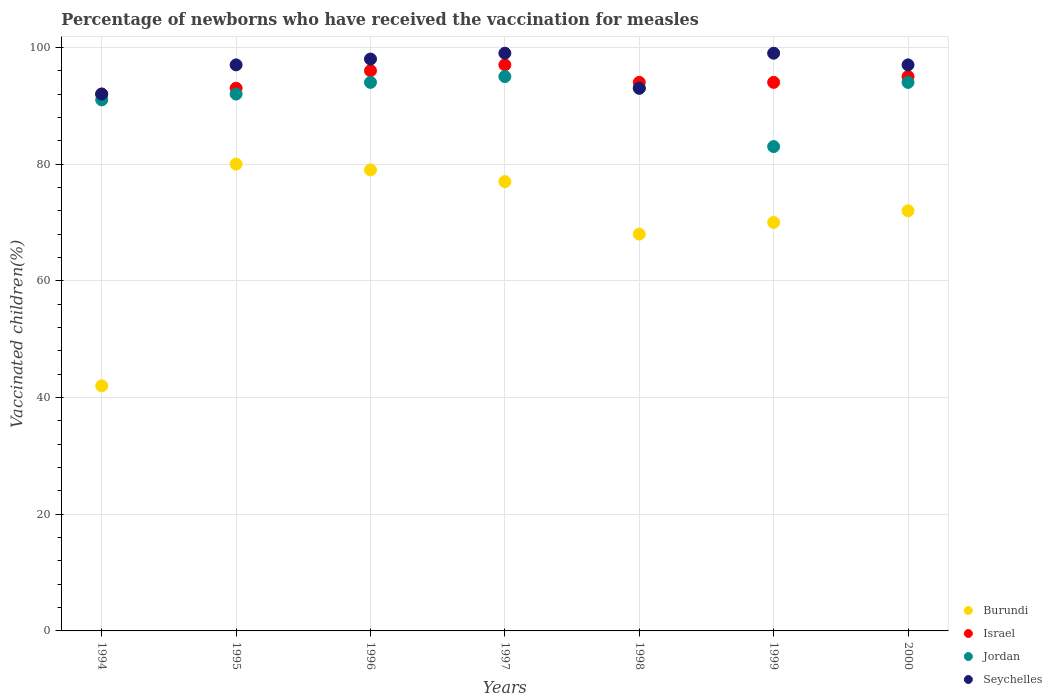How many different coloured dotlines are there?
Your response must be concise. 4. What is the percentage of vaccinated children in Israel in 1996?
Provide a succinct answer. 96. Across all years, what is the maximum percentage of vaccinated children in Burundi?
Provide a succinct answer. 80. Across all years, what is the minimum percentage of vaccinated children in Israel?
Provide a short and direct response. 92. In which year was the percentage of vaccinated children in Israel minimum?
Make the answer very short. 1994. What is the total percentage of vaccinated children in Burundi in the graph?
Your response must be concise. 488. What is the difference between the percentage of vaccinated children in Jordan in 1996 and that in 1998?
Give a very brief answer. 1. What is the average percentage of vaccinated children in Burundi per year?
Provide a succinct answer. 69.71. In the year 2000, what is the difference between the percentage of vaccinated children in Seychelles and percentage of vaccinated children in Israel?
Offer a terse response. 2. In how many years, is the percentage of vaccinated children in Jordan greater than 92 %?
Your answer should be very brief. 4. What is the ratio of the percentage of vaccinated children in Seychelles in 1999 to that in 2000?
Offer a terse response. 1.02. Is the difference between the percentage of vaccinated children in Seychelles in 1996 and 1997 greater than the difference between the percentage of vaccinated children in Israel in 1996 and 1997?
Keep it short and to the point. No. What is the difference between the highest and the lowest percentage of vaccinated children in Burundi?
Your answer should be compact. 38. In how many years, is the percentage of vaccinated children in Seychelles greater than the average percentage of vaccinated children in Seychelles taken over all years?
Ensure brevity in your answer.  5. Is the sum of the percentage of vaccinated children in Israel in 1996 and 2000 greater than the maximum percentage of vaccinated children in Jordan across all years?
Offer a terse response. Yes. Is it the case that in every year, the sum of the percentage of vaccinated children in Seychelles and percentage of vaccinated children in Israel  is greater than the sum of percentage of vaccinated children in Jordan and percentage of vaccinated children in Burundi?
Give a very brief answer. No. Is it the case that in every year, the sum of the percentage of vaccinated children in Seychelles and percentage of vaccinated children in Jordan  is greater than the percentage of vaccinated children in Burundi?
Offer a terse response. Yes. Is the percentage of vaccinated children in Seychelles strictly less than the percentage of vaccinated children in Jordan over the years?
Offer a very short reply. No. How many dotlines are there?
Provide a short and direct response. 4. How many years are there in the graph?
Your answer should be very brief. 7. What is the difference between two consecutive major ticks on the Y-axis?
Provide a succinct answer. 20. Does the graph contain any zero values?
Make the answer very short. No. Does the graph contain grids?
Provide a short and direct response. Yes. How are the legend labels stacked?
Keep it short and to the point. Vertical. What is the title of the graph?
Your answer should be very brief. Percentage of newborns who have received the vaccination for measles. Does "Low & middle income" appear as one of the legend labels in the graph?
Offer a terse response. No. What is the label or title of the Y-axis?
Your answer should be very brief. Vaccinated children(%). What is the Vaccinated children(%) of Burundi in 1994?
Your answer should be very brief. 42. What is the Vaccinated children(%) in Israel in 1994?
Offer a very short reply. 92. What is the Vaccinated children(%) of Jordan in 1994?
Provide a succinct answer. 91. What is the Vaccinated children(%) in Seychelles in 1994?
Ensure brevity in your answer.  92. What is the Vaccinated children(%) in Burundi in 1995?
Give a very brief answer. 80. What is the Vaccinated children(%) of Israel in 1995?
Make the answer very short. 93. What is the Vaccinated children(%) in Jordan in 1995?
Make the answer very short. 92. What is the Vaccinated children(%) in Seychelles in 1995?
Keep it short and to the point. 97. What is the Vaccinated children(%) in Burundi in 1996?
Offer a very short reply. 79. What is the Vaccinated children(%) of Israel in 1996?
Give a very brief answer. 96. What is the Vaccinated children(%) of Jordan in 1996?
Your response must be concise. 94. What is the Vaccinated children(%) in Seychelles in 1996?
Provide a succinct answer. 98. What is the Vaccinated children(%) of Israel in 1997?
Ensure brevity in your answer.  97. What is the Vaccinated children(%) in Jordan in 1997?
Your answer should be very brief. 95. What is the Vaccinated children(%) of Seychelles in 1997?
Your answer should be compact. 99. What is the Vaccinated children(%) in Burundi in 1998?
Your answer should be very brief. 68. What is the Vaccinated children(%) of Israel in 1998?
Provide a short and direct response. 94. What is the Vaccinated children(%) in Jordan in 1998?
Provide a short and direct response. 93. What is the Vaccinated children(%) of Seychelles in 1998?
Keep it short and to the point. 93. What is the Vaccinated children(%) in Burundi in 1999?
Offer a terse response. 70. What is the Vaccinated children(%) in Israel in 1999?
Your answer should be very brief. 94. What is the Vaccinated children(%) of Jordan in 1999?
Provide a short and direct response. 83. What is the Vaccinated children(%) in Israel in 2000?
Make the answer very short. 95. What is the Vaccinated children(%) of Jordan in 2000?
Provide a succinct answer. 94. What is the Vaccinated children(%) in Seychelles in 2000?
Offer a very short reply. 97. Across all years, what is the maximum Vaccinated children(%) in Burundi?
Your response must be concise. 80. Across all years, what is the maximum Vaccinated children(%) in Israel?
Provide a succinct answer. 97. Across all years, what is the maximum Vaccinated children(%) of Seychelles?
Offer a very short reply. 99. Across all years, what is the minimum Vaccinated children(%) of Israel?
Ensure brevity in your answer.  92. Across all years, what is the minimum Vaccinated children(%) in Seychelles?
Your answer should be compact. 92. What is the total Vaccinated children(%) in Burundi in the graph?
Give a very brief answer. 488. What is the total Vaccinated children(%) in Israel in the graph?
Your answer should be very brief. 661. What is the total Vaccinated children(%) of Jordan in the graph?
Provide a succinct answer. 642. What is the total Vaccinated children(%) in Seychelles in the graph?
Your answer should be compact. 675. What is the difference between the Vaccinated children(%) of Burundi in 1994 and that in 1995?
Ensure brevity in your answer.  -38. What is the difference between the Vaccinated children(%) in Israel in 1994 and that in 1995?
Your answer should be very brief. -1. What is the difference between the Vaccinated children(%) in Jordan in 1994 and that in 1995?
Offer a terse response. -1. What is the difference between the Vaccinated children(%) of Burundi in 1994 and that in 1996?
Offer a very short reply. -37. What is the difference between the Vaccinated children(%) of Seychelles in 1994 and that in 1996?
Offer a very short reply. -6. What is the difference between the Vaccinated children(%) in Burundi in 1994 and that in 1997?
Your answer should be very brief. -35. What is the difference between the Vaccinated children(%) in Jordan in 1994 and that in 1997?
Your answer should be compact. -4. What is the difference between the Vaccinated children(%) of Seychelles in 1994 and that in 1997?
Provide a short and direct response. -7. What is the difference between the Vaccinated children(%) in Burundi in 1994 and that in 1998?
Provide a short and direct response. -26. What is the difference between the Vaccinated children(%) in Seychelles in 1994 and that in 1998?
Ensure brevity in your answer.  -1. What is the difference between the Vaccinated children(%) of Burundi in 1994 and that in 1999?
Give a very brief answer. -28. What is the difference between the Vaccinated children(%) in Jordan in 1994 and that in 1999?
Give a very brief answer. 8. What is the difference between the Vaccinated children(%) in Seychelles in 1994 and that in 1999?
Make the answer very short. -7. What is the difference between the Vaccinated children(%) of Burundi in 1994 and that in 2000?
Your response must be concise. -30. What is the difference between the Vaccinated children(%) in Jordan in 1994 and that in 2000?
Offer a terse response. -3. What is the difference between the Vaccinated children(%) of Seychelles in 1994 and that in 2000?
Your answer should be very brief. -5. What is the difference between the Vaccinated children(%) in Jordan in 1995 and that in 1996?
Ensure brevity in your answer.  -2. What is the difference between the Vaccinated children(%) of Seychelles in 1995 and that in 1996?
Provide a succinct answer. -1. What is the difference between the Vaccinated children(%) in Burundi in 1995 and that in 1997?
Keep it short and to the point. 3. What is the difference between the Vaccinated children(%) in Israel in 1995 and that in 1997?
Offer a terse response. -4. What is the difference between the Vaccinated children(%) in Jordan in 1995 and that in 1997?
Ensure brevity in your answer.  -3. What is the difference between the Vaccinated children(%) of Burundi in 1995 and that in 1998?
Provide a succinct answer. 12. What is the difference between the Vaccinated children(%) of Israel in 1995 and that in 1998?
Your response must be concise. -1. What is the difference between the Vaccinated children(%) in Jordan in 1995 and that in 1998?
Give a very brief answer. -1. What is the difference between the Vaccinated children(%) in Seychelles in 1995 and that in 1998?
Your response must be concise. 4. What is the difference between the Vaccinated children(%) in Israel in 1995 and that in 2000?
Keep it short and to the point. -2. What is the difference between the Vaccinated children(%) of Jordan in 1995 and that in 2000?
Your answer should be compact. -2. What is the difference between the Vaccinated children(%) of Seychelles in 1995 and that in 2000?
Your answer should be very brief. 0. What is the difference between the Vaccinated children(%) of Israel in 1996 and that in 1997?
Provide a succinct answer. -1. What is the difference between the Vaccinated children(%) of Seychelles in 1996 and that in 1997?
Your answer should be very brief. -1. What is the difference between the Vaccinated children(%) in Burundi in 1996 and that in 1998?
Give a very brief answer. 11. What is the difference between the Vaccinated children(%) of Jordan in 1996 and that in 1998?
Ensure brevity in your answer.  1. What is the difference between the Vaccinated children(%) of Burundi in 1996 and that in 1999?
Offer a terse response. 9. What is the difference between the Vaccinated children(%) of Israel in 1996 and that in 1999?
Your answer should be very brief. 2. What is the difference between the Vaccinated children(%) of Seychelles in 1996 and that in 1999?
Make the answer very short. -1. What is the difference between the Vaccinated children(%) of Israel in 1996 and that in 2000?
Give a very brief answer. 1. What is the difference between the Vaccinated children(%) of Israel in 1997 and that in 1998?
Provide a short and direct response. 3. What is the difference between the Vaccinated children(%) of Burundi in 1997 and that in 1999?
Keep it short and to the point. 7. What is the difference between the Vaccinated children(%) of Jordan in 1997 and that in 1999?
Ensure brevity in your answer.  12. What is the difference between the Vaccinated children(%) in Seychelles in 1997 and that in 1999?
Your answer should be very brief. 0. What is the difference between the Vaccinated children(%) of Burundi in 1997 and that in 2000?
Your answer should be compact. 5. What is the difference between the Vaccinated children(%) in Jordan in 1997 and that in 2000?
Provide a short and direct response. 1. What is the difference between the Vaccinated children(%) of Burundi in 1998 and that in 1999?
Ensure brevity in your answer.  -2. What is the difference between the Vaccinated children(%) in Burundi in 1998 and that in 2000?
Your answer should be very brief. -4. What is the difference between the Vaccinated children(%) in Jordan in 1998 and that in 2000?
Your answer should be compact. -1. What is the difference between the Vaccinated children(%) of Burundi in 1999 and that in 2000?
Your response must be concise. -2. What is the difference between the Vaccinated children(%) in Israel in 1999 and that in 2000?
Your answer should be compact. -1. What is the difference between the Vaccinated children(%) in Jordan in 1999 and that in 2000?
Your response must be concise. -11. What is the difference between the Vaccinated children(%) of Burundi in 1994 and the Vaccinated children(%) of Israel in 1995?
Give a very brief answer. -51. What is the difference between the Vaccinated children(%) of Burundi in 1994 and the Vaccinated children(%) of Seychelles in 1995?
Give a very brief answer. -55. What is the difference between the Vaccinated children(%) of Jordan in 1994 and the Vaccinated children(%) of Seychelles in 1995?
Keep it short and to the point. -6. What is the difference between the Vaccinated children(%) of Burundi in 1994 and the Vaccinated children(%) of Israel in 1996?
Give a very brief answer. -54. What is the difference between the Vaccinated children(%) in Burundi in 1994 and the Vaccinated children(%) in Jordan in 1996?
Make the answer very short. -52. What is the difference between the Vaccinated children(%) in Burundi in 1994 and the Vaccinated children(%) in Seychelles in 1996?
Keep it short and to the point. -56. What is the difference between the Vaccinated children(%) of Israel in 1994 and the Vaccinated children(%) of Seychelles in 1996?
Keep it short and to the point. -6. What is the difference between the Vaccinated children(%) of Jordan in 1994 and the Vaccinated children(%) of Seychelles in 1996?
Give a very brief answer. -7. What is the difference between the Vaccinated children(%) of Burundi in 1994 and the Vaccinated children(%) of Israel in 1997?
Keep it short and to the point. -55. What is the difference between the Vaccinated children(%) of Burundi in 1994 and the Vaccinated children(%) of Jordan in 1997?
Make the answer very short. -53. What is the difference between the Vaccinated children(%) in Burundi in 1994 and the Vaccinated children(%) in Seychelles in 1997?
Provide a succinct answer. -57. What is the difference between the Vaccinated children(%) in Jordan in 1994 and the Vaccinated children(%) in Seychelles in 1997?
Offer a very short reply. -8. What is the difference between the Vaccinated children(%) in Burundi in 1994 and the Vaccinated children(%) in Israel in 1998?
Keep it short and to the point. -52. What is the difference between the Vaccinated children(%) in Burundi in 1994 and the Vaccinated children(%) in Jordan in 1998?
Ensure brevity in your answer.  -51. What is the difference between the Vaccinated children(%) in Burundi in 1994 and the Vaccinated children(%) in Seychelles in 1998?
Provide a short and direct response. -51. What is the difference between the Vaccinated children(%) of Jordan in 1994 and the Vaccinated children(%) of Seychelles in 1998?
Give a very brief answer. -2. What is the difference between the Vaccinated children(%) of Burundi in 1994 and the Vaccinated children(%) of Israel in 1999?
Provide a succinct answer. -52. What is the difference between the Vaccinated children(%) in Burundi in 1994 and the Vaccinated children(%) in Jordan in 1999?
Make the answer very short. -41. What is the difference between the Vaccinated children(%) of Burundi in 1994 and the Vaccinated children(%) of Seychelles in 1999?
Ensure brevity in your answer.  -57. What is the difference between the Vaccinated children(%) of Burundi in 1994 and the Vaccinated children(%) of Israel in 2000?
Ensure brevity in your answer.  -53. What is the difference between the Vaccinated children(%) in Burundi in 1994 and the Vaccinated children(%) in Jordan in 2000?
Ensure brevity in your answer.  -52. What is the difference between the Vaccinated children(%) in Burundi in 1994 and the Vaccinated children(%) in Seychelles in 2000?
Offer a very short reply. -55. What is the difference between the Vaccinated children(%) of Jordan in 1994 and the Vaccinated children(%) of Seychelles in 2000?
Make the answer very short. -6. What is the difference between the Vaccinated children(%) of Burundi in 1995 and the Vaccinated children(%) of Seychelles in 1996?
Ensure brevity in your answer.  -18. What is the difference between the Vaccinated children(%) of Burundi in 1995 and the Vaccinated children(%) of Jordan in 1997?
Make the answer very short. -15. What is the difference between the Vaccinated children(%) of Burundi in 1995 and the Vaccinated children(%) of Seychelles in 1997?
Provide a short and direct response. -19. What is the difference between the Vaccinated children(%) of Israel in 1995 and the Vaccinated children(%) of Jordan in 1997?
Offer a very short reply. -2. What is the difference between the Vaccinated children(%) in Israel in 1995 and the Vaccinated children(%) in Seychelles in 1998?
Provide a short and direct response. 0. What is the difference between the Vaccinated children(%) of Israel in 1995 and the Vaccinated children(%) of Jordan in 1999?
Your answer should be compact. 10. What is the difference between the Vaccinated children(%) of Burundi in 1995 and the Vaccinated children(%) of Israel in 2000?
Your answer should be compact. -15. What is the difference between the Vaccinated children(%) in Burundi in 1995 and the Vaccinated children(%) in Jordan in 2000?
Keep it short and to the point. -14. What is the difference between the Vaccinated children(%) in Israel in 1995 and the Vaccinated children(%) in Seychelles in 2000?
Give a very brief answer. -4. What is the difference between the Vaccinated children(%) in Jordan in 1995 and the Vaccinated children(%) in Seychelles in 2000?
Your answer should be compact. -5. What is the difference between the Vaccinated children(%) of Burundi in 1996 and the Vaccinated children(%) of Jordan in 1997?
Ensure brevity in your answer.  -16. What is the difference between the Vaccinated children(%) of Israel in 1996 and the Vaccinated children(%) of Seychelles in 1997?
Your answer should be compact. -3. What is the difference between the Vaccinated children(%) of Jordan in 1996 and the Vaccinated children(%) of Seychelles in 1997?
Give a very brief answer. -5. What is the difference between the Vaccinated children(%) in Burundi in 1996 and the Vaccinated children(%) in Jordan in 1998?
Give a very brief answer. -14. What is the difference between the Vaccinated children(%) of Burundi in 1996 and the Vaccinated children(%) of Seychelles in 1998?
Your answer should be compact. -14. What is the difference between the Vaccinated children(%) of Israel in 1996 and the Vaccinated children(%) of Jordan in 1998?
Ensure brevity in your answer.  3. What is the difference between the Vaccinated children(%) of Israel in 1996 and the Vaccinated children(%) of Seychelles in 1998?
Your response must be concise. 3. What is the difference between the Vaccinated children(%) in Burundi in 1996 and the Vaccinated children(%) in Israel in 1999?
Offer a terse response. -15. What is the difference between the Vaccinated children(%) of Israel in 1996 and the Vaccinated children(%) of Jordan in 1999?
Give a very brief answer. 13. What is the difference between the Vaccinated children(%) in Jordan in 1996 and the Vaccinated children(%) in Seychelles in 1999?
Give a very brief answer. -5. What is the difference between the Vaccinated children(%) of Burundi in 1996 and the Vaccinated children(%) of Jordan in 2000?
Provide a short and direct response. -15. What is the difference between the Vaccinated children(%) in Burundi in 1996 and the Vaccinated children(%) in Seychelles in 2000?
Provide a succinct answer. -18. What is the difference between the Vaccinated children(%) in Israel in 1996 and the Vaccinated children(%) in Jordan in 2000?
Give a very brief answer. 2. What is the difference between the Vaccinated children(%) in Israel in 1996 and the Vaccinated children(%) in Seychelles in 2000?
Give a very brief answer. -1. What is the difference between the Vaccinated children(%) of Burundi in 1997 and the Vaccinated children(%) of Israel in 1998?
Keep it short and to the point. -17. What is the difference between the Vaccinated children(%) in Burundi in 1997 and the Vaccinated children(%) in Jordan in 1998?
Offer a very short reply. -16. What is the difference between the Vaccinated children(%) in Israel in 1997 and the Vaccinated children(%) in Seychelles in 1998?
Offer a terse response. 4. What is the difference between the Vaccinated children(%) of Jordan in 1997 and the Vaccinated children(%) of Seychelles in 1998?
Your answer should be very brief. 2. What is the difference between the Vaccinated children(%) of Burundi in 1997 and the Vaccinated children(%) of Jordan in 1999?
Provide a short and direct response. -6. What is the difference between the Vaccinated children(%) of Burundi in 1997 and the Vaccinated children(%) of Seychelles in 1999?
Your answer should be very brief. -22. What is the difference between the Vaccinated children(%) in Israel in 1997 and the Vaccinated children(%) in Jordan in 1999?
Ensure brevity in your answer.  14. What is the difference between the Vaccinated children(%) in Israel in 1997 and the Vaccinated children(%) in Seychelles in 1999?
Give a very brief answer. -2. What is the difference between the Vaccinated children(%) of Burundi in 1997 and the Vaccinated children(%) of Israel in 2000?
Give a very brief answer. -18. What is the difference between the Vaccinated children(%) of Burundi in 1997 and the Vaccinated children(%) of Jordan in 2000?
Offer a terse response. -17. What is the difference between the Vaccinated children(%) of Burundi in 1997 and the Vaccinated children(%) of Seychelles in 2000?
Offer a terse response. -20. What is the difference between the Vaccinated children(%) in Israel in 1997 and the Vaccinated children(%) in Jordan in 2000?
Provide a short and direct response. 3. What is the difference between the Vaccinated children(%) of Israel in 1997 and the Vaccinated children(%) of Seychelles in 2000?
Offer a terse response. 0. What is the difference between the Vaccinated children(%) of Burundi in 1998 and the Vaccinated children(%) of Seychelles in 1999?
Offer a very short reply. -31. What is the difference between the Vaccinated children(%) in Israel in 1998 and the Vaccinated children(%) in Seychelles in 1999?
Make the answer very short. -5. What is the difference between the Vaccinated children(%) in Burundi in 1998 and the Vaccinated children(%) in Israel in 2000?
Ensure brevity in your answer.  -27. What is the difference between the Vaccinated children(%) in Israel in 1998 and the Vaccinated children(%) in Jordan in 2000?
Keep it short and to the point. 0. What is the difference between the Vaccinated children(%) in Israel in 1998 and the Vaccinated children(%) in Seychelles in 2000?
Your answer should be very brief. -3. What is the difference between the Vaccinated children(%) of Burundi in 1999 and the Vaccinated children(%) of Israel in 2000?
Keep it short and to the point. -25. What is the difference between the Vaccinated children(%) in Israel in 1999 and the Vaccinated children(%) in Seychelles in 2000?
Offer a terse response. -3. What is the difference between the Vaccinated children(%) of Jordan in 1999 and the Vaccinated children(%) of Seychelles in 2000?
Provide a succinct answer. -14. What is the average Vaccinated children(%) in Burundi per year?
Ensure brevity in your answer.  69.71. What is the average Vaccinated children(%) in Israel per year?
Make the answer very short. 94.43. What is the average Vaccinated children(%) of Jordan per year?
Offer a terse response. 91.71. What is the average Vaccinated children(%) in Seychelles per year?
Offer a very short reply. 96.43. In the year 1994, what is the difference between the Vaccinated children(%) of Burundi and Vaccinated children(%) of Israel?
Give a very brief answer. -50. In the year 1994, what is the difference between the Vaccinated children(%) in Burundi and Vaccinated children(%) in Jordan?
Your answer should be compact. -49. In the year 1994, what is the difference between the Vaccinated children(%) of Israel and Vaccinated children(%) of Seychelles?
Provide a short and direct response. 0. In the year 1994, what is the difference between the Vaccinated children(%) in Jordan and Vaccinated children(%) in Seychelles?
Your response must be concise. -1. In the year 1995, what is the difference between the Vaccinated children(%) of Burundi and Vaccinated children(%) of Israel?
Provide a short and direct response. -13. In the year 1995, what is the difference between the Vaccinated children(%) in Burundi and Vaccinated children(%) in Seychelles?
Your answer should be compact. -17. In the year 1995, what is the difference between the Vaccinated children(%) in Israel and Vaccinated children(%) in Seychelles?
Give a very brief answer. -4. In the year 1996, what is the difference between the Vaccinated children(%) in Burundi and Vaccinated children(%) in Israel?
Your answer should be compact. -17. In the year 1996, what is the difference between the Vaccinated children(%) of Burundi and Vaccinated children(%) of Seychelles?
Offer a very short reply. -19. In the year 1996, what is the difference between the Vaccinated children(%) of Israel and Vaccinated children(%) of Seychelles?
Your answer should be very brief. -2. In the year 1996, what is the difference between the Vaccinated children(%) in Jordan and Vaccinated children(%) in Seychelles?
Offer a terse response. -4. In the year 1997, what is the difference between the Vaccinated children(%) in Burundi and Vaccinated children(%) in Jordan?
Ensure brevity in your answer.  -18. In the year 1997, what is the difference between the Vaccinated children(%) in Burundi and Vaccinated children(%) in Seychelles?
Ensure brevity in your answer.  -22. In the year 1997, what is the difference between the Vaccinated children(%) in Israel and Vaccinated children(%) in Jordan?
Provide a short and direct response. 2. In the year 1997, what is the difference between the Vaccinated children(%) in Jordan and Vaccinated children(%) in Seychelles?
Offer a terse response. -4. In the year 1998, what is the difference between the Vaccinated children(%) in Burundi and Vaccinated children(%) in Israel?
Provide a succinct answer. -26. In the year 1999, what is the difference between the Vaccinated children(%) of Burundi and Vaccinated children(%) of Jordan?
Give a very brief answer. -13. In the year 1999, what is the difference between the Vaccinated children(%) of Burundi and Vaccinated children(%) of Seychelles?
Provide a short and direct response. -29. In the year 1999, what is the difference between the Vaccinated children(%) in Israel and Vaccinated children(%) in Seychelles?
Ensure brevity in your answer.  -5. In the year 2000, what is the difference between the Vaccinated children(%) of Burundi and Vaccinated children(%) of Israel?
Keep it short and to the point. -23. In the year 2000, what is the difference between the Vaccinated children(%) in Burundi and Vaccinated children(%) in Jordan?
Your answer should be very brief. -22. In the year 2000, what is the difference between the Vaccinated children(%) of Israel and Vaccinated children(%) of Seychelles?
Offer a very short reply. -2. In the year 2000, what is the difference between the Vaccinated children(%) of Jordan and Vaccinated children(%) of Seychelles?
Your answer should be compact. -3. What is the ratio of the Vaccinated children(%) in Burundi in 1994 to that in 1995?
Offer a terse response. 0.53. What is the ratio of the Vaccinated children(%) of Israel in 1994 to that in 1995?
Offer a terse response. 0.99. What is the ratio of the Vaccinated children(%) in Seychelles in 1994 to that in 1995?
Your response must be concise. 0.95. What is the ratio of the Vaccinated children(%) of Burundi in 1994 to that in 1996?
Make the answer very short. 0.53. What is the ratio of the Vaccinated children(%) in Jordan in 1994 to that in 1996?
Ensure brevity in your answer.  0.97. What is the ratio of the Vaccinated children(%) in Seychelles in 1994 to that in 1996?
Give a very brief answer. 0.94. What is the ratio of the Vaccinated children(%) of Burundi in 1994 to that in 1997?
Offer a very short reply. 0.55. What is the ratio of the Vaccinated children(%) of Israel in 1994 to that in 1997?
Make the answer very short. 0.95. What is the ratio of the Vaccinated children(%) in Jordan in 1994 to that in 1997?
Ensure brevity in your answer.  0.96. What is the ratio of the Vaccinated children(%) of Seychelles in 1994 to that in 1997?
Make the answer very short. 0.93. What is the ratio of the Vaccinated children(%) of Burundi in 1994 to that in 1998?
Give a very brief answer. 0.62. What is the ratio of the Vaccinated children(%) in Israel in 1994 to that in 1998?
Your response must be concise. 0.98. What is the ratio of the Vaccinated children(%) in Jordan in 1994 to that in 1998?
Offer a very short reply. 0.98. What is the ratio of the Vaccinated children(%) in Seychelles in 1994 to that in 1998?
Provide a short and direct response. 0.99. What is the ratio of the Vaccinated children(%) of Israel in 1994 to that in 1999?
Provide a short and direct response. 0.98. What is the ratio of the Vaccinated children(%) in Jordan in 1994 to that in 1999?
Give a very brief answer. 1.1. What is the ratio of the Vaccinated children(%) in Seychelles in 1994 to that in 1999?
Keep it short and to the point. 0.93. What is the ratio of the Vaccinated children(%) in Burundi in 1994 to that in 2000?
Give a very brief answer. 0.58. What is the ratio of the Vaccinated children(%) of Israel in 1994 to that in 2000?
Keep it short and to the point. 0.97. What is the ratio of the Vaccinated children(%) of Jordan in 1994 to that in 2000?
Make the answer very short. 0.97. What is the ratio of the Vaccinated children(%) in Seychelles in 1994 to that in 2000?
Keep it short and to the point. 0.95. What is the ratio of the Vaccinated children(%) of Burundi in 1995 to that in 1996?
Give a very brief answer. 1.01. What is the ratio of the Vaccinated children(%) in Israel in 1995 to that in 1996?
Your response must be concise. 0.97. What is the ratio of the Vaccinated children(%) in Jordan in 1995 to that in 1996?
Keep it short and to the point. 0.98. What is the ratio of the Vaccinated children(%) of Seychelles in 1995 to that in 1996?
Keep it short and to the point. 0.99. What is the ratio of the Vaccinated children(%) of Burundi in 1995 to that in 1997?
Your response must be concise. 1.04. What is the ratio of the Vaccinated children(%) in Israel in 1995 to that in 1997?
Keep it short and to the point. 0.96. What is the ratio of the Vaccinated children(%) in Jordan in 1995 to that in 1997?
Your answer should be very brief. 0.97. What is the ratio of the Vaccinated children(%) in Seychelles in 1995 to that in 1997?
Offer a terse response. 0.98. What is the ratio of the Vaccinated children(%) of Burundi in 1995 to that in 1998?
Provide a short and direct response. 1.18. What is the ratio of the Vaccinated children(%) in Seychelles in 1995 to that in 1998?
Ensure brevity in your answer.  1.04. What is the ratio of the Vaccinated children(%) in Israel in 1995 to that in 1999?
Ensure brevity in your answer.  0.99. What is the ratio of the Vaccinated children(%) in Jordan in 1995 to that in 1999?
Offer a terse response. 1.11. What is the ratio of the Vaccinated children(%) in Seychelles in 1995 to that in 1999?
Offer a very short reply. 0.98. What is the ratio of the Vaccinated children(%) in Israel in 1995 to that in 2000?
Offer a terse response. 0.98. What is the ratio of the Vaccinated children(%) of Jordan in 1995 to that in 2000?
Offer a terse response. 0.98. What is the ratio of the Vaccinated children(%) in Seychelles in 1995 to that in 2000?
Ensure brevity in your answer.  1. What is the ratio of the Vaccinated children(%) of Israel in 1996 to that in 1997?
Offer a very short reply. 0.99. What is the ratio of the Vaccinated children(%) in Jordan in 1996 to that in 1997?
Offer a terse response. 0.99. What is the ratio of the Vaccinated children(%) of Seychelles in 1996 to that in 1997?
Your answer should be very brief. 0.99. What is the ratio of the Vaccinated children(%) of Burundi in 1996 to that in 1998?
Your response must be concise. 1.16. What is the ratio of the Vaccinated children(%) in Israel in 1996 to that in 1998?
Provide a succinct answer. 1.02. What is the ratio of the Vaccinated children(%) in Jordan in 1996 to that in 1998?
Offer a terse response. 1.01. What is the ratio of the Vaccinated children(%) of Seychelles in 1996 to that in 1998?
Ensure brevity in your answer.  1.05. What is the ratio of the Vaccinated children(%) of Burundi in 1996 to that in 1999?
Provide a succinct answer. 1.13. What is the ratio of the Vaccinated children(%) in Israel in 1996 to that in 1999?
Provide a short and direct response. 1.02. What is the ratio of the Vaccinated children(%) in Jordan in 1996 to that in 1999?
Your answer should be very brief. 1.13. What is the ratio of the Vaccinated children(%) in Seychelles in 1996 to that in 1999?
Offer a very short reply. 0.99. What is the ratio of the Vaccinated children(%) in Burundi in 1996 to that in 2000?
Provide a short and direct response. 1.1. What is the ratio of the Vaccinated children(%) of Israel in 1996 to that in 2000?
Offer a terse response. 1.01. What is the ratio of the Vaccinated children(%) in Jordan in 1996 to that in 2000?
Ensure brevity in your answer.  1. What is the ratio of the Vaccinated children(%) of Seychelles in 1996 to that in 2000?
Provide a succinct answer. 1.01. What is the ratio of the Vaccinated children(%) in Burundi in 1997 to that in 1998?
Offer a very short reply. 1.13. What is the ratio of the Vaccinated children(%) in Israel in 1997 to that in 1998?
Ensure brevity in your answer.  1.03. What is the ratio of the Vaccinated children(%) of Jordan in 1997 to that in 1998?
Offer a very short reply. 1.02. What is the ratio of the Vaccinated children(%) of Seychelles in 1997 to that in 1998?
Make the answer very short. 1.06. What is the ratio of the Vaccinated children(%) of Burundi in 1997 to that in 1999?
Offer a terse response. 1.1. What is the ratio of the Vaccinated children(%) of Israel in 1997 to that in 1999?
Your answer should be very brief. 1.03. What is the ratio of the Vaccinated children(%) in Jordan in 1997 to that in 1999?
Offer a terse response. 1.14. What is the ratio of the Vaccinated children(%) in Seychelles in 1997 to that in 1999?
Provide a short and direct response. 1. What is the ratio of the Vaccinated children(%) of Burundi in 1997 to that in 2000?
Keep it short and to the point. 1.07. What is the ratio of the Vaccinated children(%) in Israel in 1997 to that in 2000?
Offer a terse response. 1.02. What is the ratio of the Vaccinated children(%) in Jordan in 1997 to that in 2000?
Give a very brief answer. 1.01. What is the ratio of the Vaccinated children(%) in Seychelles in 1997 to that in 2000?
Keep it short and to the point. 1.02. What is the ratio of the Vaccinated children(%) in Burundi in 1998 to that in 1999?
Give a very brief answer. 0.97. What is the ratio of the Vaccinated children(%) of Jordan in 1998 to that in 1999?
Provide a succinct answer. 1.12. What is the ratio of the Vaccinated children(%) in Seychelles in 1998 to that in 1999?
Ensure brevity in your answer.  0.94. What is the ratio of the Vaccinated children(%) in Burundi in 1998 to that in 2000?
Offer a very short reply. 0.94. What is the ratio of the Vaccinated children(%) of Seychelles in 1998 to that in 2000?
Make the answer very short. 0.96. What is the ratio of the Vaccinated children(%) in Burundi in 1999 to that in 2000?
Provide a succinct answer. 0.97. What is the ratio of the Vaccinated children(%) in Israel in 1999 to that in 2000?
Ensure brevity in your answer.  0.99. What is the ratio of the Vaccinated children(%) in Jordan in 1999 to that in 2000?
Keep it short and to the point. 0.88. What is the ratio of the Vaccinated children(%) of Seychelles in 1999 to that in 2000?
Keep it short and to the point. 1.02. What is the difference between the highest and the second highest Vaccinated children(%) in Jordan?
Offer a terse response. 1. What is the difference between the highest and the lowest Vaccinated children(%) in Burundi?
Your response must be concise. 38. What is the difference between the highest and the lowest Vaccinated children(%) of Israel?
Provide a short and direct response. 5. What is the difference between the highest and the lowest Vaccinated children(%) of Seychelles?
Provide a succinct answer. 7. 